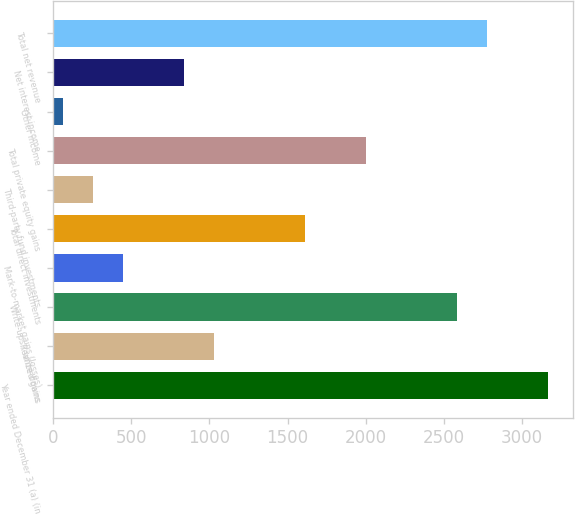Convert chart. <chart><loc_0><loc_0><loc_500><loc_500><bar_chart><fcel>Year ended December 31 (a) (in<fcel>Realized gains<fcel>Write-ups / write-downs<fcel>Mark-to-market gains (losses)<fcel>Total direct investments<fcel>Third-party fund investments<fcel>Total private equity gains<fcel>Other income<fcel>Net interest income<fcel>Total net revenue<nl><fcel>3167.8<fcel>1030.5<fcel>2584.9<fcel>447.6<fcel>1613.4<fcel>253.3<fcel>2002<fcel>59<fcel>836.2<fcel>2779.2<nl></chart> 